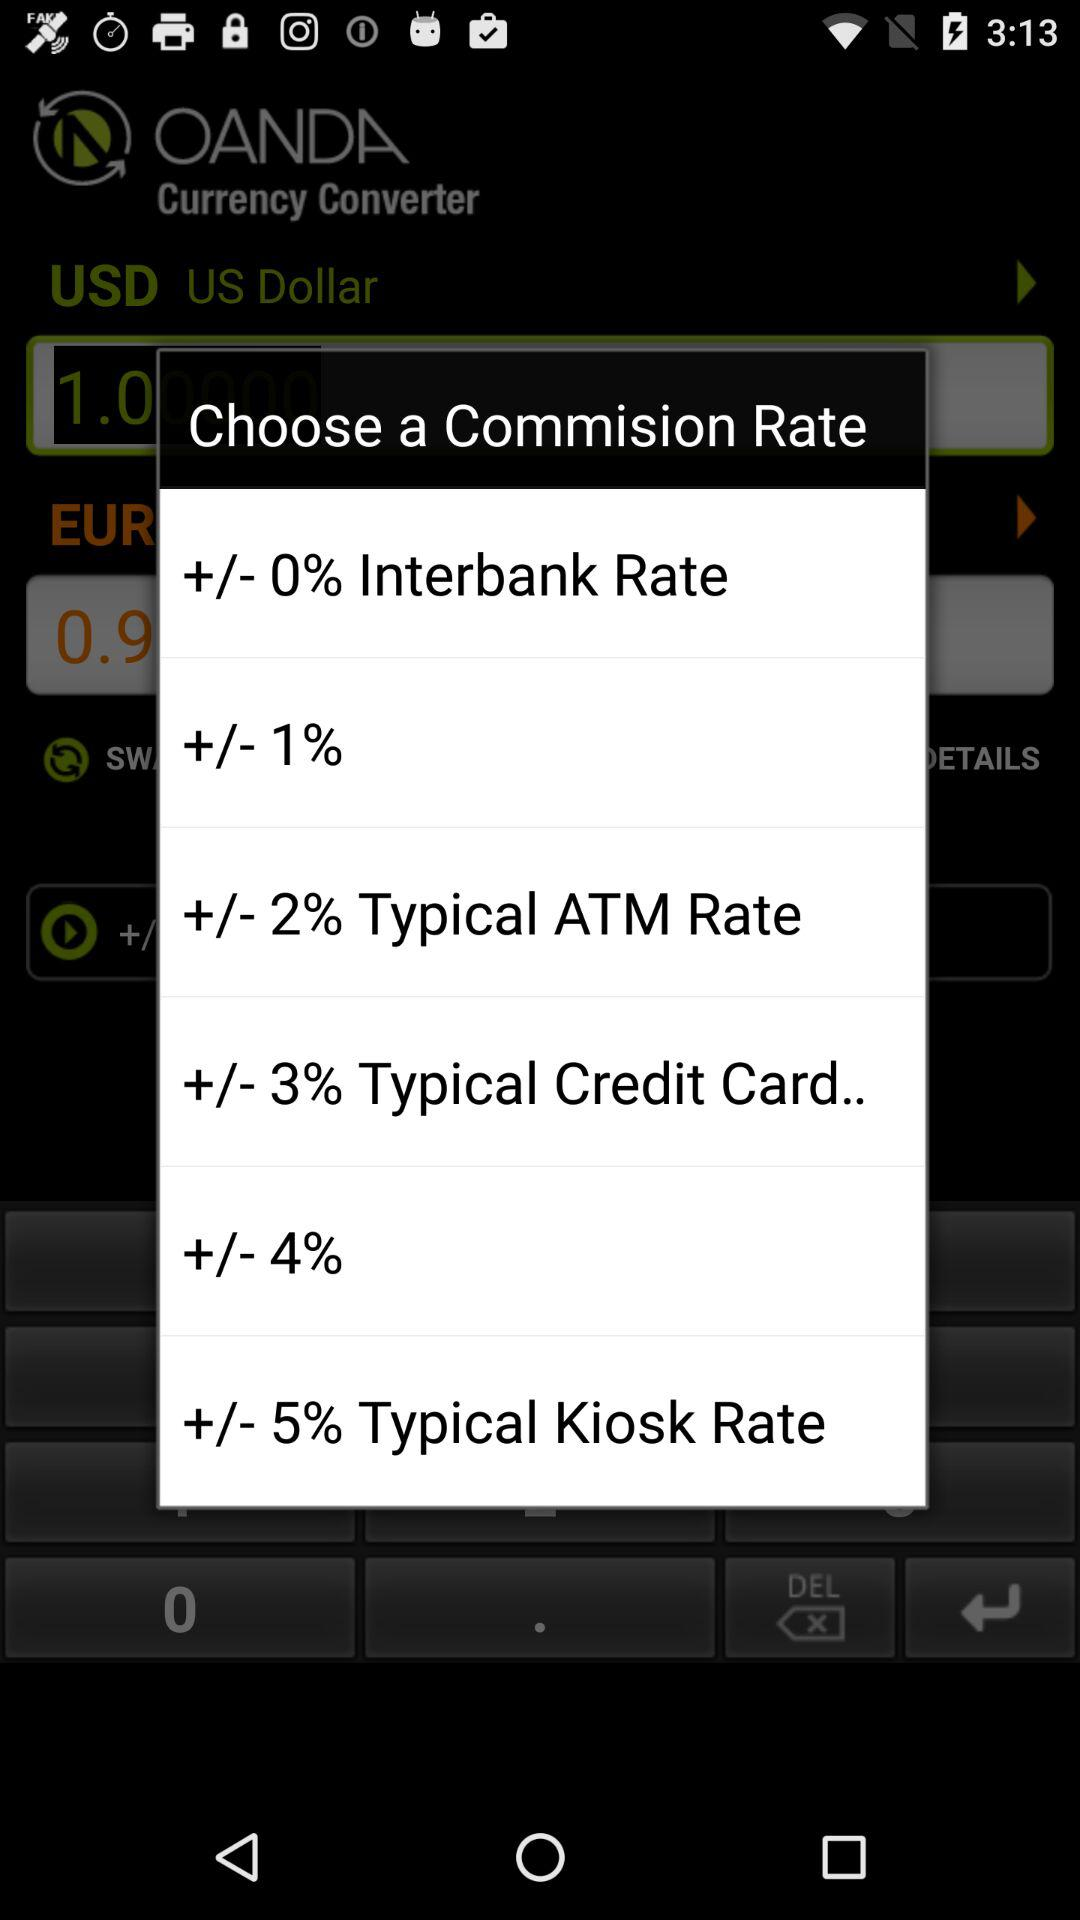What is the version of this application?
When the provided information is insufficient, respond with <no answer>. <no answer> 